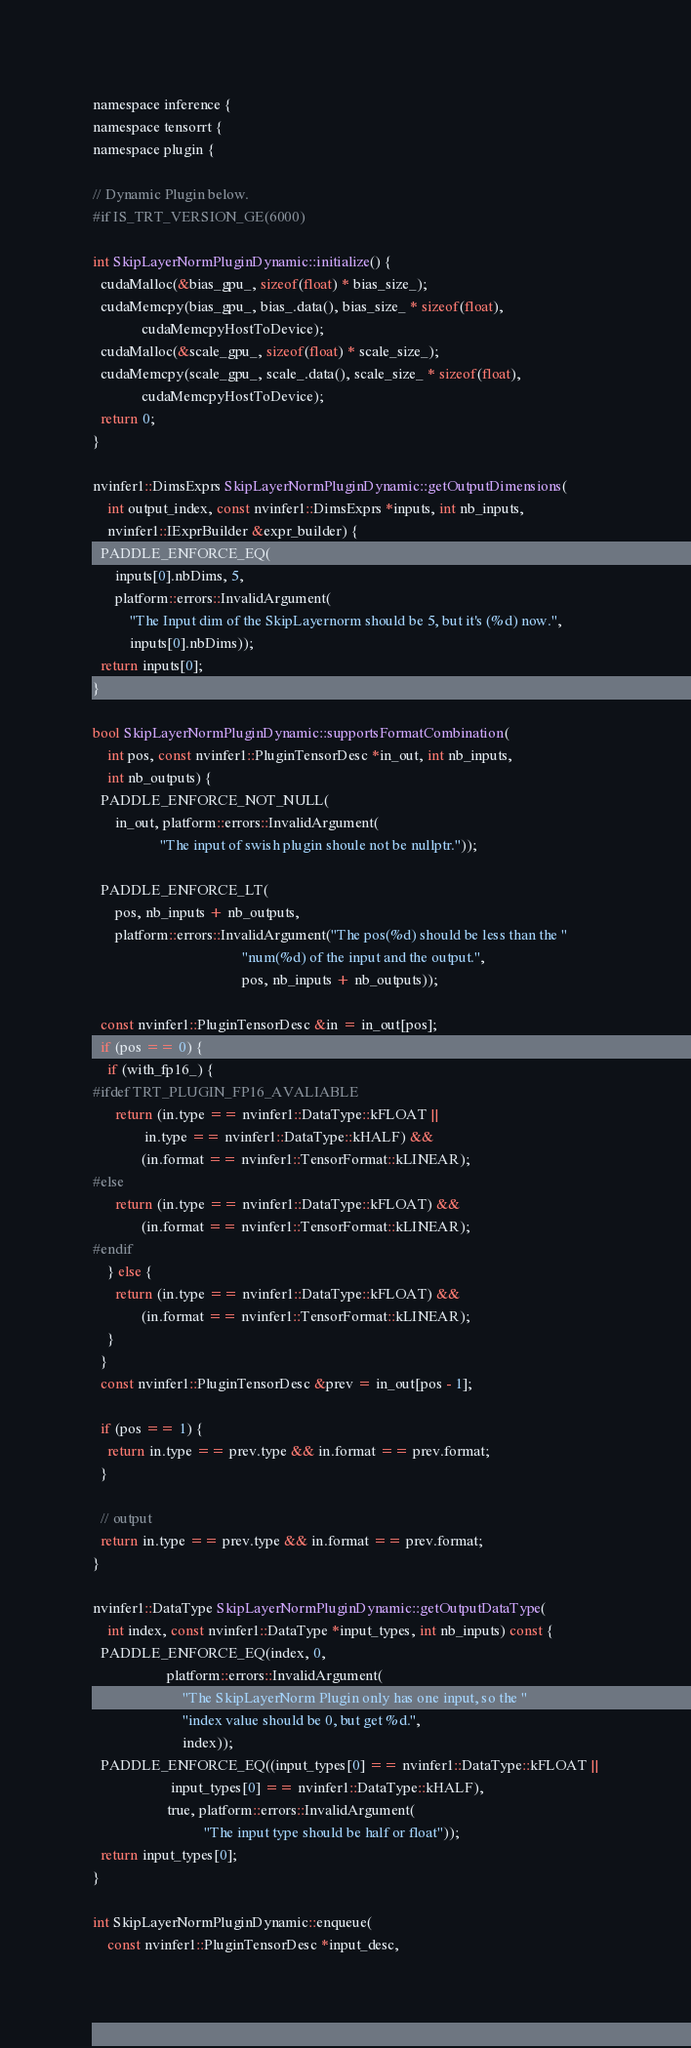Convert code to text. <code><loc_0><loc_0><loc_500><loc_500><_Cuda_>namespace inference {
namespace tensorrt {
namespace plugin {

// Dynamic Plugin below.
#if IS_TRT_VERSION_GE(6000)

int SkipLayerNormPluginDynamic::initialize() {
  cudaMalloc(&bias_gpu_, sizeof(float) * bias_size_);
  cudaMemcpy(bias_gpu_, bias_.data(), bias_size_ * sizeof(float),
             cudaMemcpyHostToDevice);
  cudaMalloc(&scale_gpu_, sizeof(float) * scale_size_);
  cudaMemcpy(scale_gpu_, scale_.data(), scale_size_ * sizeof(float),
             cudaMemcpyHostToDevice);
  return 0;
}

nvinfer1::DimsExprs SkipLayerNormPluginDynamic::getOutputDimensions(
    int output_index, const nvinfer1::DimsExprs *inputs, int nb_inputs,
    nvinfer1::IExprBuilder &expr_builder) {
  PADDLE_ENFORCE_EQ(
      inputs[0].nbDims, 5,
      platform::errors::InvalidArgument(
          "The Input dim of the SkipLayernorm should be 5, but it's (%d) now.",
          inputs[0].nbDims));
  return inputs[0];
}

bool SkipLayerNormPluginDynamic::supportsFormatCombination(
    int pos, const nvinfer1::PluginTensorDesc *in_out, int nb_inputs,
    int nb_outputs) {
  PADDLE_ENFORCE_NOT_NULL(
      in_out, platform::errors::InvalidArgument(
                  "The input of swish plugin shoule not be nullptr."));

  PADDLE_ENFORCE_LT(
      pos, nb_inputs + nb_outputs,
      platform::errors::InvalidArgument("The pos(%d) should be less than the "
                                        "num(%d) of the input and the output.",
                                        pos, nb_inputs + nb_outputs));

  const nvinfer1::PluginTensorDesc &in = in_out[pos];
  if (pos == 0) {
    if (with_fp16_) {
#ifdef TRT_PLUGIN_FP16_AVALIABLE
      return (in.type == nvinfer1::DataType::kFLOAT ||
              in.type == nvinfer1::DataType::kHALF) &&
             (in.format == nvinfer1::TensorFormat::kLINEAR);
#else
      return (in.type == nvinfer1::DataType::kFLOAT) &&
             (in.format == nvinfer1::TensorFormat::kLINEAR);
#endif
    } else {
      return (in.type == nvinfer1::DataType::kFLOAT) &&
             (in.format == nvinfer1::TensorFormat::kLINEAR);
    }
  }
  const nvinfer1::PluginTensorDesc &prev = in_out[pos - 1];

  if (pos == 1) {
    return in.type == prev.type && in.format == prev.format;
  }

  // output
  return in.type == prev.type && in.format == prev.format;
}

nvinfer1::DataType SkipLayerNormPluginDynamic::getOutputDataType(
    int index, const nvinfer1::DataType *input_types, int nb_inputs) const {
  PADDLE_ENFORCE_EQ(index, 0,
                    platform::errors::InvalidArgument(
                        "The SkipLayerNorm Plugin only has one input, so the "
                        "index value should be 0, but get %d.",
                        index));
  PADDLE_ENFORCE_EQ((input_types[0] == nvinfer1::DataType::kFLOAT ||
                     input_types[0] == nvinfer1::DataType::kHALF),
                    true, platform::errors::InvalidArgument(
                              "The input type should be half or float"));
  return input_types[0];
}

int SkipLayerNormPluginDynamic::enqueue(
    const nvinfer1::PluginTensorDesc *input_desc,</code> 